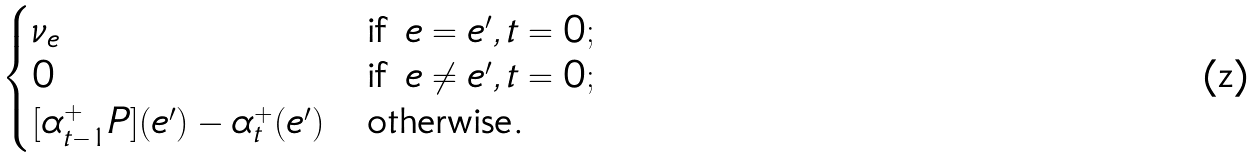Convert formula to latex. <formula><loc_0><loc_0><loc_500><loc_500>\begin{cases} \nu _ { e } & \text {if } e = e ^ { \prime } , t = 0 ; \\ 0 & \text {if } e \ne e ^ { \prime } , t = 0 ; \\ [ \alpha _ { t - 1 } ^ { + } P ] ( e ^ { \prime } ) - \alpha _ { t } ^ { + } ( e ^ { \prime } ) & \text {otherwise.} \end{cases}</formula> 